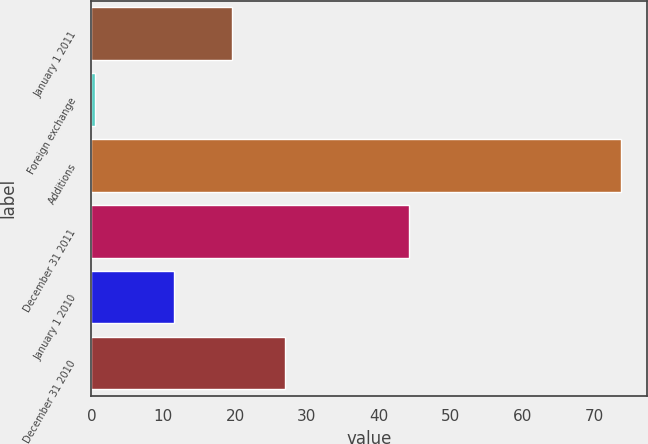Convert chart. <chart><loc_0><loc_0><loc_500><loc_500><bar_chart><fcel>January 1 2011<fcel>Foreign exchange<fcel>Additions<fcel>December 31 2011<fcel>January 1 2010<fcel>December 31 2010<nl><fcel>19.6<fcel>0.5<fcel>73.7<fcel>44.2<fcel>11.5<fcel>26.92<nl></chart> 